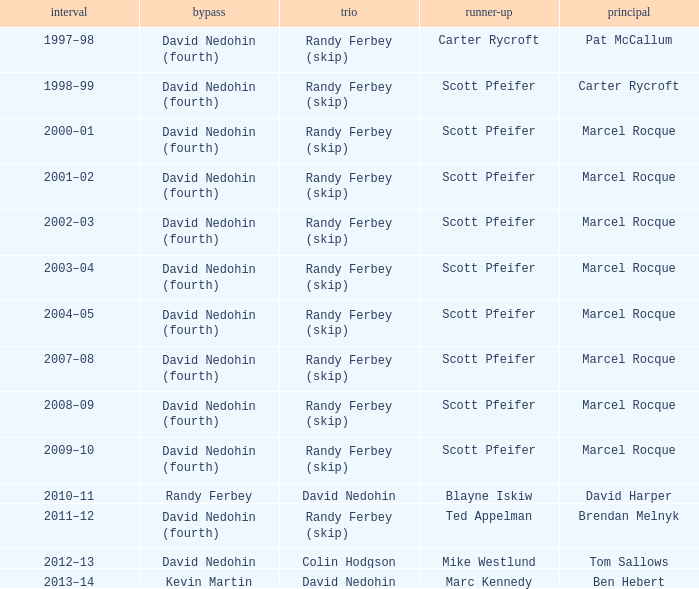Which Season has a Third of colin hodgson? 2012–13. 